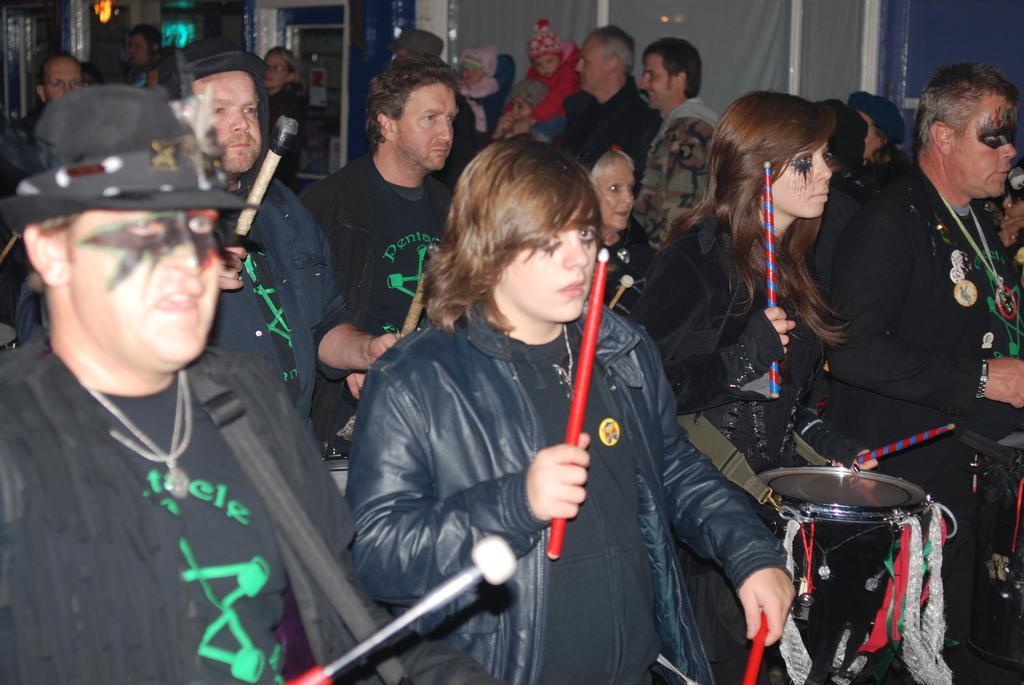Please provide a concise description of this image. This picture shows many people playing drums, holding sticks in their hands. There are men and women in this group. In the background there are people standing here. 